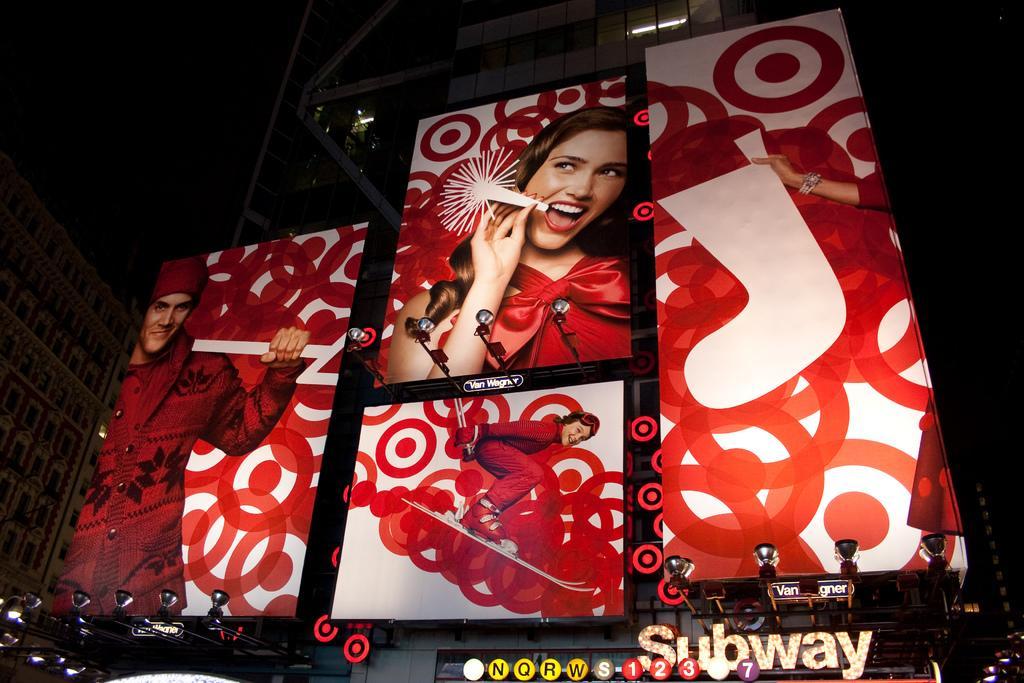Describe this image in one or two sentences. In this image in front there are hoardings. There are numbers and letters on the metal rod. In the background of the image there are buildings. On the left side of the image there are focus lamps. 